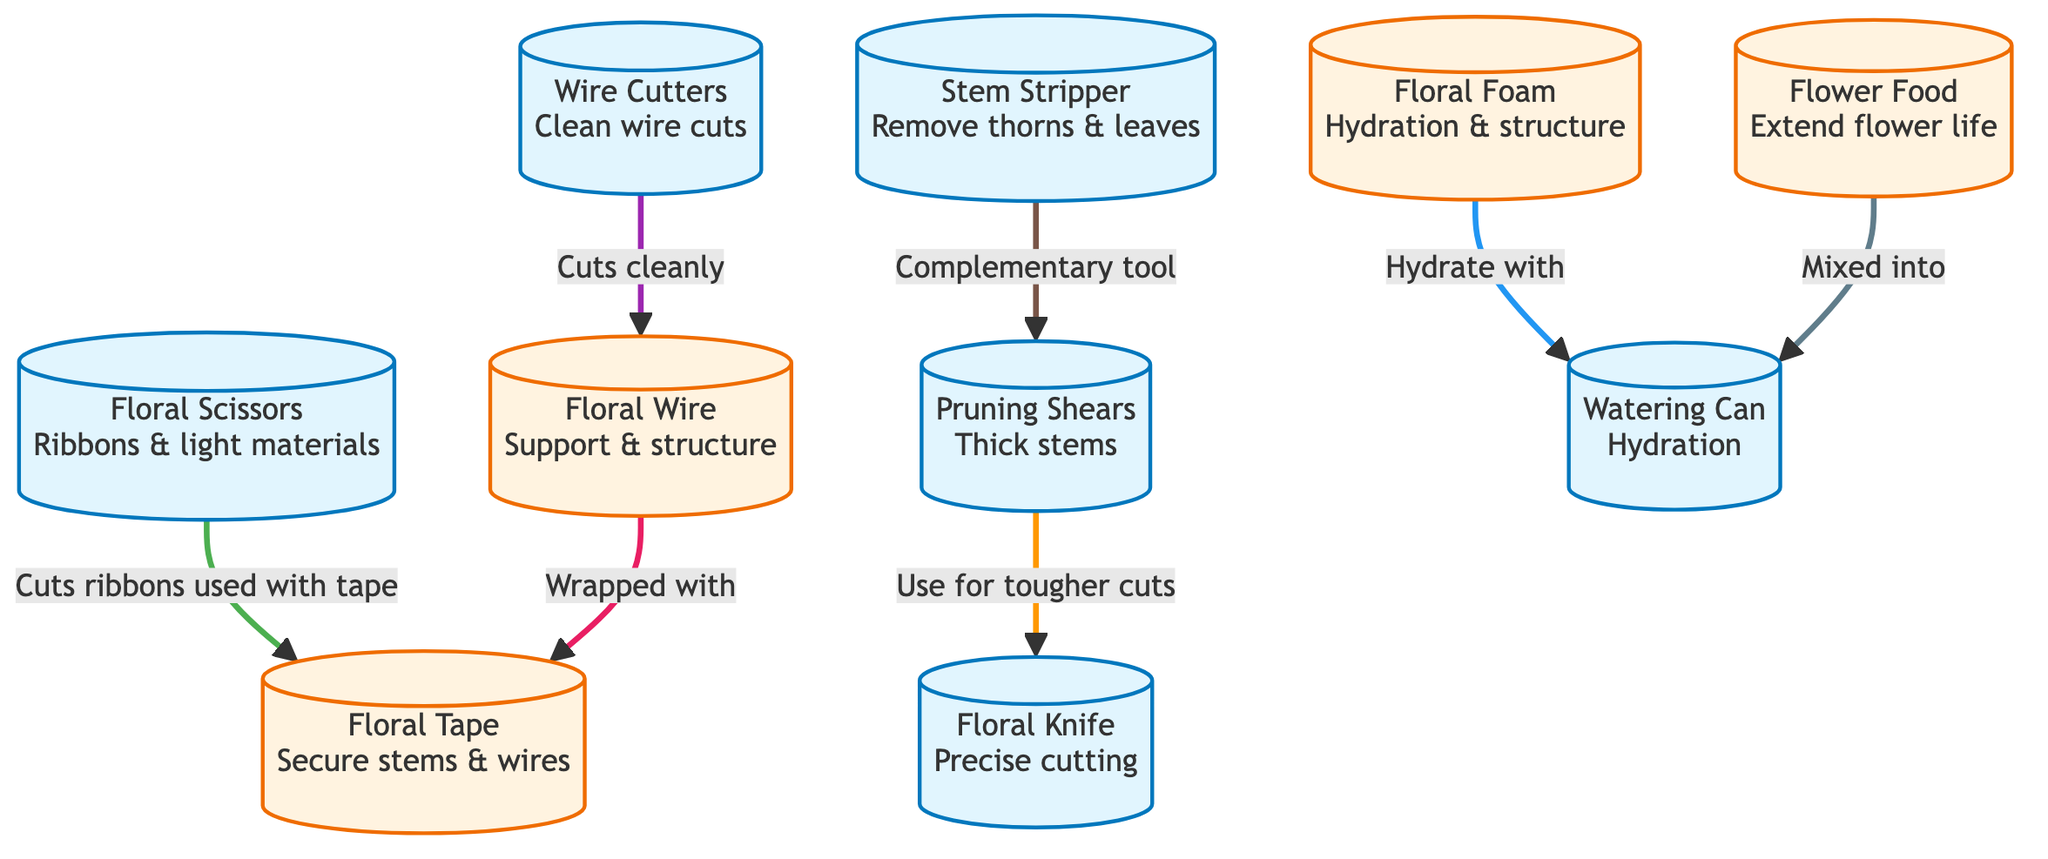What tool is used for precise cutting? The diagram identifies the "Floral Knife" as the tool specifically dedicated to "Precise cutting." Hence, the answer can be found directly under the node labeled with this information.
Answer: Floral Knife How many tools are depicted in the diagram? By observing the diagram, there are eight distinct tools listed: Floral Knife, Pruning Shears, Floral Scissors, Floral Tape, Wire Cutters, Stem Stripper, Watering Can, and Floral Foam. Therefore, to find the total number, count the nodes categorized under tools.
Answer: 8 Which tool is intended for cutting thick stems? The "Pruning Shears" is indicated as the tool specifically meant for “Thick stems.” This can be confirmed by looking at the description associated with this tool in the diagram.
Answer: Pruning Shears What is the purpose of the watering can? The diagram shows "Hydration" as the specific use for the "Watering Can." This means the watering can is connected to the purpose of watering plants or flowers, indicated clearly in the node description.
Answer: Hydration Which tool complements the pruning shears? According to the diagram, the "Stem Stripper" is described as a "Complementary tool" to the "Pruning Shears," indicating that both tools work together during the floral preparation process.
Answer: Stem Stripper How is the floral wire typically used in conjunction with other materials? The diagram indicates that "Floral Wire" is "Wrapped with Floral Tape." This interaction highlights the relationship of how one material is applied to support the use of another, which displays their combined use in floral design.
Answer: Wrapped with Floral Tape What does the floral foam provide to floral arrangements? The diagram specifies that "Floral Foam" serves for "Hydration & structure." This focuses on the dual roles of the foam in providing moisture to flowers while also giving them a structural base in arrangements.
Answer: Hydration & structure Which tool is designed for cutting ribbons? The diagram indicates that "Floral Scissors" are used for "Ribbons & light materials." This information directly correlates the tool with its intended cutting purpose based on the description.
Answer: Floral Scissors What is normally mixed into the watering can for flower care? "Flower Food" is specified in the diagram as being "Mixed into" the watering can, indicating this is a common practice to enhance the lifespan of flowers when they are hydrated.
Answer: Mixed into Watering Can 